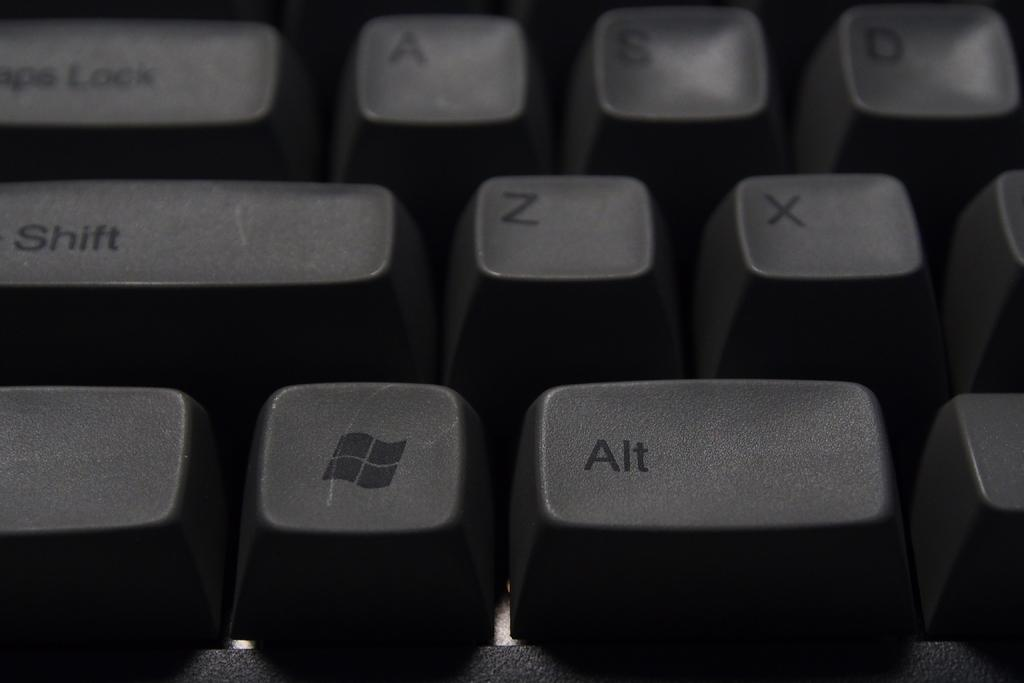<image>
Give a short and clear explanation of the subsequent image. close up of a keyboard with the alt key at the bottom right 